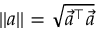Convert formula to latex. <formula><loc_0><loc_0><loc_500><loc_500>| | a | | = \sqrt { \vec { a } ^ { \top } \vec { a } }</formula> 